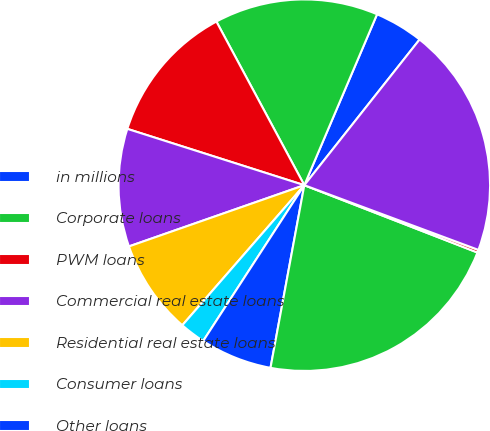Convert chart. <chart><loc_0><loc_0><loc_500><loc_500><pie_chart><fcel>in millions<fcel>Corporate loans<fcel>PWM loans<fcel>Commercial real estate loans<fcel>Residential real estate loans<fcel>Consumer loans<fcel>Other loans<fcel>Total loans receivable gross<fcel>Allowance for loan losses<fcel>Total loans receivable<nl><fcel>4.25%<fcel>14.25%<fcel>12.25%<fcel>10.25%<fcel>8.25%<fcel>2.24%<fcel>6.25%<fcel>22.01%<fcel>0.24%<fcel>20.01%<nl></chart> 